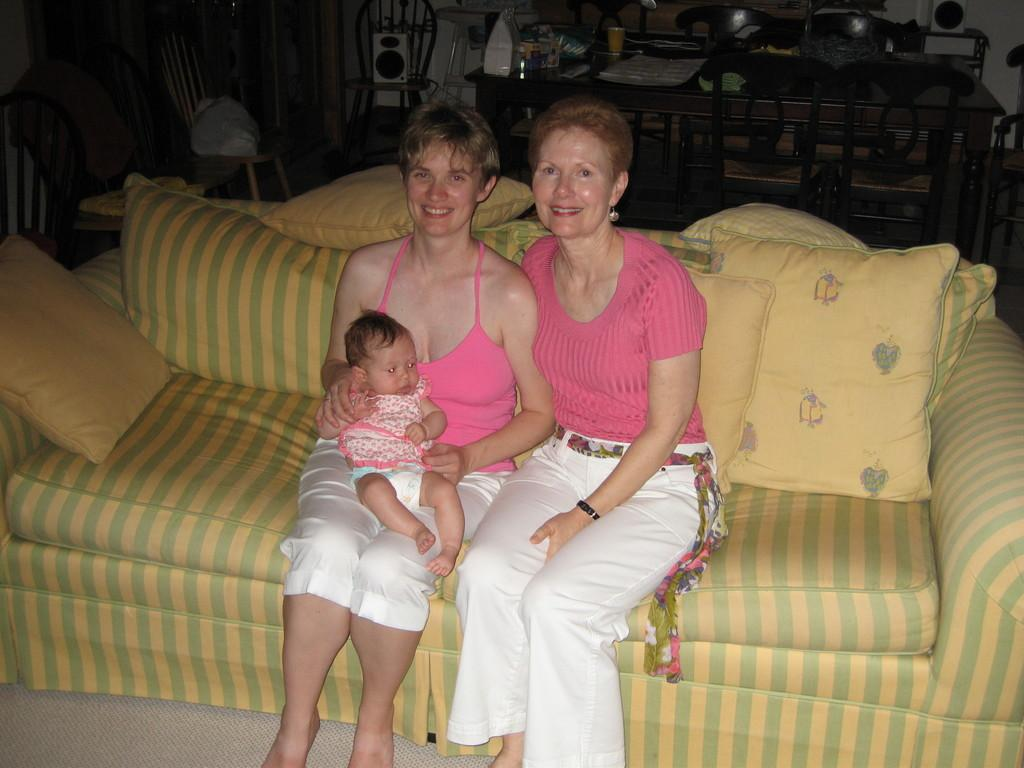How many women are present in the image? There are two women in the image. What are the women doing in the image? The women are sitting on a sofa. Is there a child present in the image? Yes, one woman is carrying a child. What can be seen in the background of the image? There are tables and chairs in the background of the image. What shape is the beetle crawling on the sofa in the image? There is no beetle present in the image, so it cannot be determined what shape it might be crawling on. 